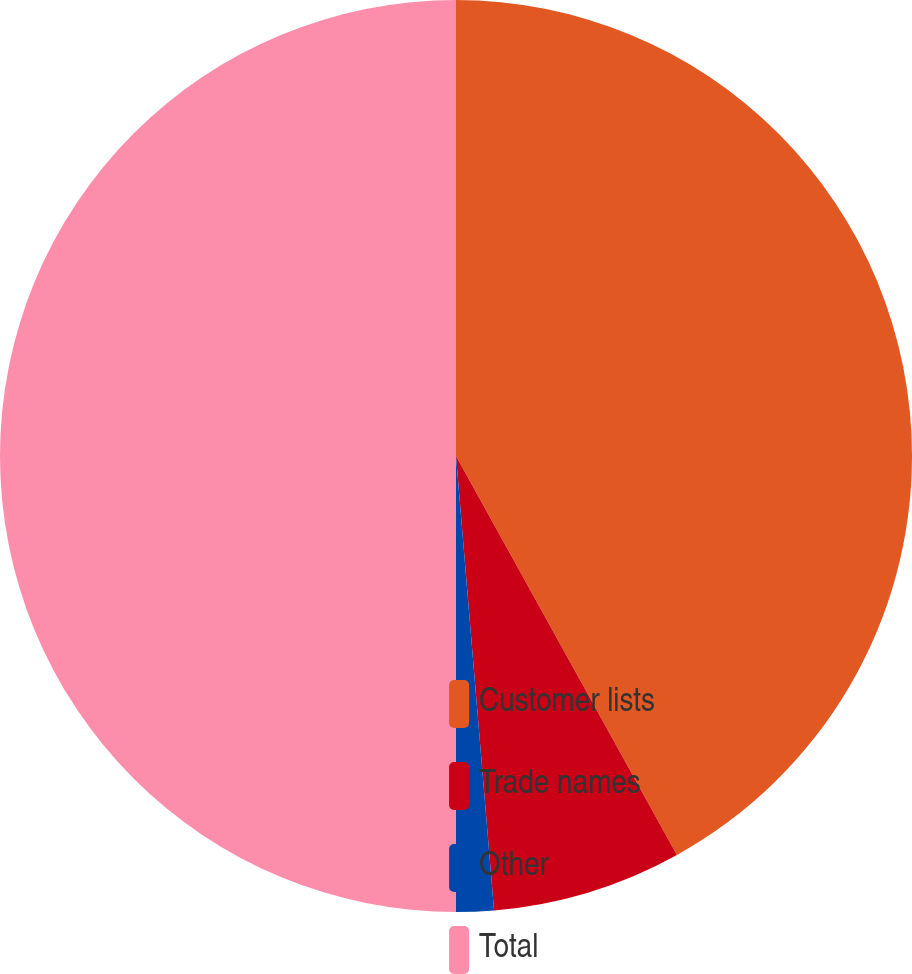Convert chart. <chart><loc_0><loc_0><loc_500><loc_500><pie_chart><fcel>Customer lists<fcel>Trade names<fcel>Other<fcel>Total<nl><fcel>41.95%<fcel>6.72%<fcel>1.33%<fcel>50.0%<nl></chart> 